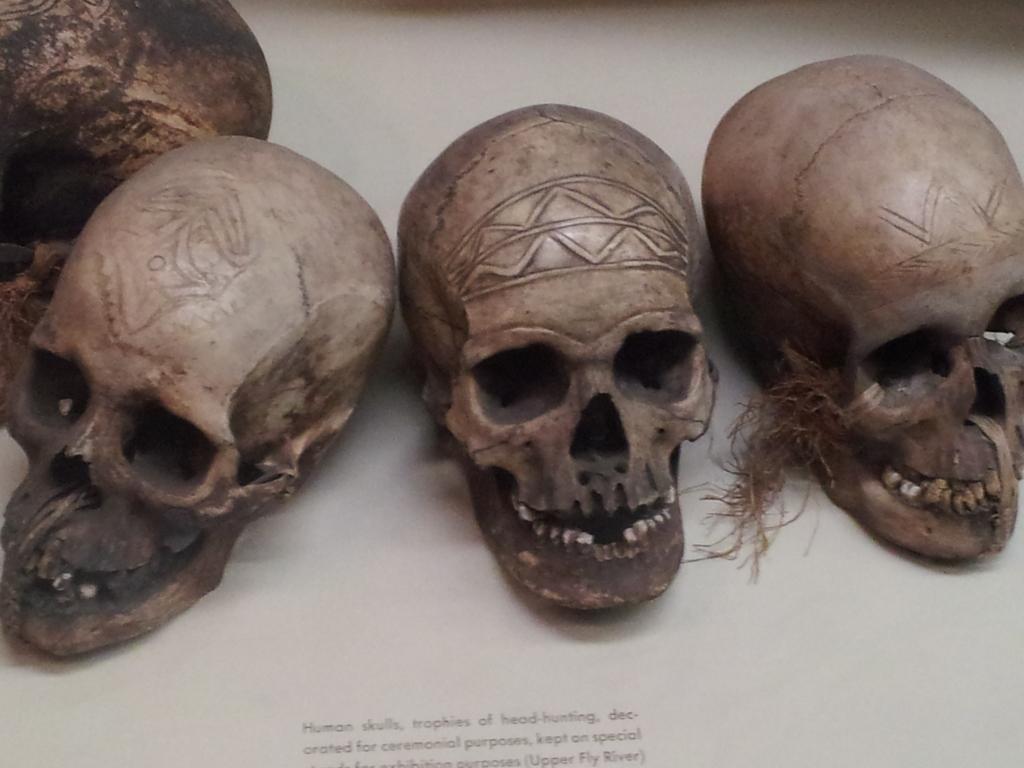Describe this image in one or two sentences. In this picture I can see the four person's head skulls which is kept on the table. At the bottom I can see something is written. 